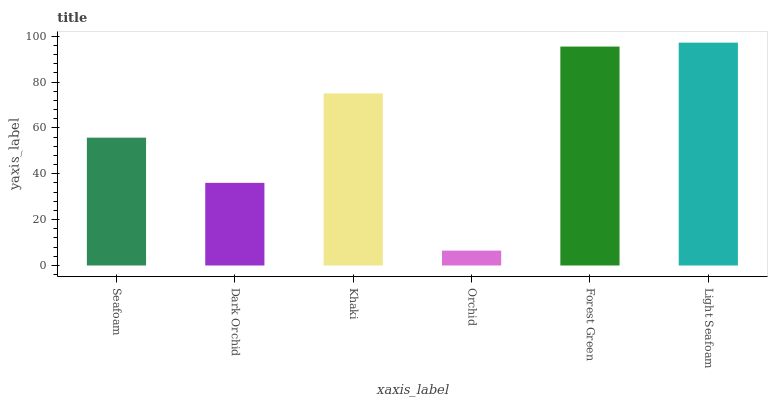Is Orchid the minimum?
Answer yes or no. Yes. Is Light Seafoam the maximum?
Answer yes or no. Yes. Is Dark Orchid the minimum?
Answer yes or no. No. Is Dark Orchid the maximum?
Answer yes or no. No. Is Seafoam greater than Dark Orchid?
Answer yes or no. Yes. Is Dark Orchid less than Seafoam?
Answer yes or no. Yes. Is Dark Orchid greater than Seafoam?
Answer yes or no. No. Is Seafoam less than Dark Orchid?
Answer yes or no. No. Is Khaki the high median?
Answer yes or no. Yes. Is Seafoam the low median?
Answer yes or no. Yes. Is Light Seafoam the high median?
Answer yes or no. No. Is Orchid the low median?
Answer yes or no. No. 